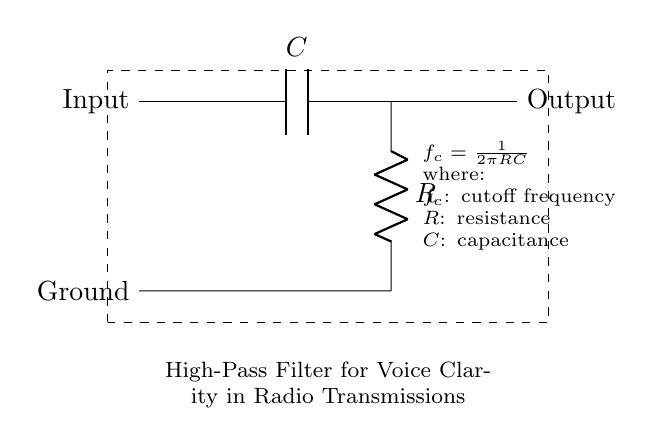What are the components present in the circuit? The circuit diagram shows a capacitor and a resistor, which are the main components of the high-pass filter design.
Answer: Capacitor, Resistor What does the "Input" node indicate? The "Input" node represents where the audio signal is fed into the circuit, marking the starting point for processing the signal.
Answer: Audio signal entry point What is the purpose of the capacitor in this circuit? The capacitor blocks low-frequency signals while allowing high-frequency signals to pass through, which is essential for enhancing voice clarity in radio transmissions.
Answer: Blocks low frequencies What is the cutoff frequency formula provided? The formula given in the diagram is used to determine the cutoff frequency, represented as f_c = 1/(2πRC), which shows the relationship between resistance, capacitance, and frequency.
Answer: f_c = 1/(2πRC) How does increasing the resistance value affect the cutoff frequency? Increasing the resistance value increases the cutoff frequency, as per the formula, resulting in more high-frequency components passing through while reducing low-frequency signals.
Answer: Increases cutoff frequency What is the significance of the output node in the circuit? The output node provides the processed signal, which after passing through the filter has improved clarity for radio transmissions, making it the point where the enhanced audio is sent out.
Answer: Processed audio signal exit point 